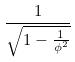<formula> <loc_0><loc_0><loc_500><loc_500>\frac { 1 } { \sqrt { 1 - \frac { 1 } { \phi ^ { 2 } } } }</formula> 